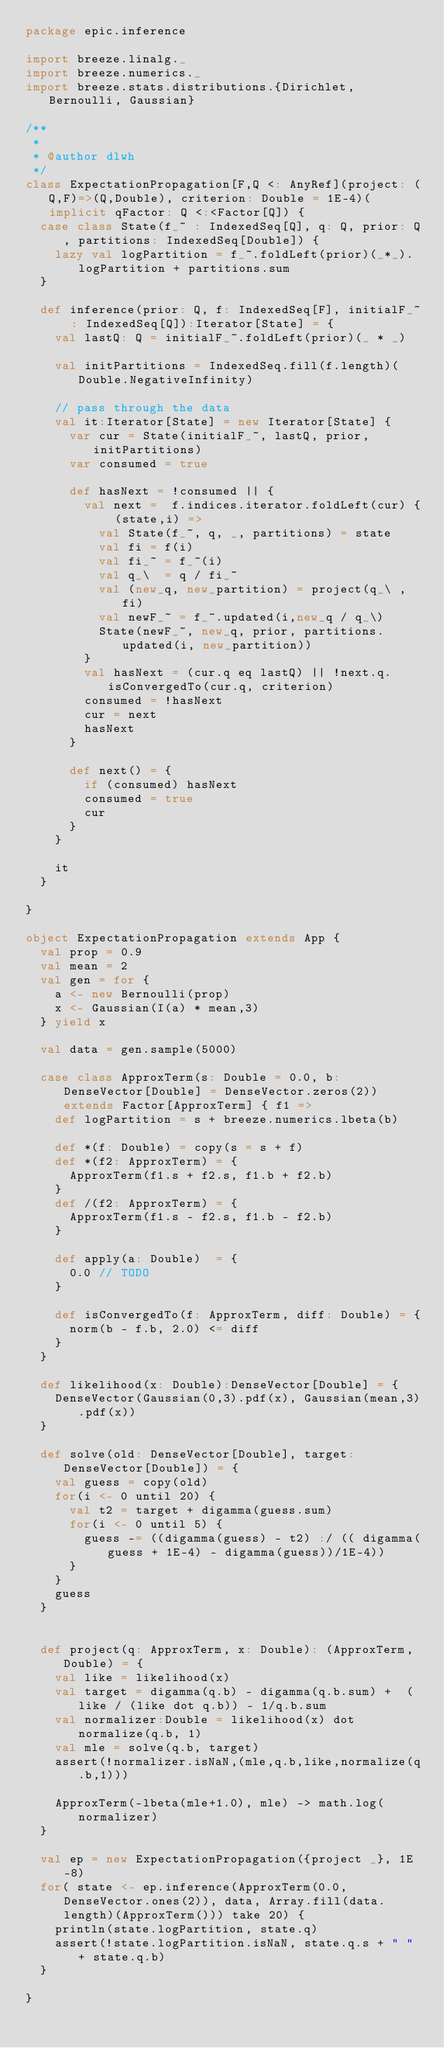<code> <loc_0><loc_0><loc_500><loc_500><_Scala_>package epic.inference

import breeze.linalg._
import breeze.numerics._
import breeze.stats.distributions.{Dirichlet, Bernoulli, Gaussian}

/**
 *
 * @author dlwh
 */
class ExpectationPropagation[F,Q <: AnyRef](project: (Q,F)=>(Q,Double), criterion: Double = 1E-4)(implicit qFactor: Q <:<Factor[Q]) {
  case class State(f_~ : IndexedSeq[Q], q: Q, prior: Q, partitions: IndexedSeq[Double]) {
    lazy val logPartition = f_~.foldLeft(prior)(_*_).logPartition + partitions.sum
  }

  def inference(prior: Q, f: IndexedSeq[F], initialF_~ : IndexedSeq[Q]):Iterator[State] = {
    val lastQ: Q = initialF_~.foldLeft(prior)(_ * _)

    val initPartitions = IndexedSeq.fill(f.length)(Double.NegativeInfinity)

    // pass through the data
    val it:Iterator[State] = new Iterator[State] {
      var cur = State(initialF_~, lastQ, prior, initPartitions)
      var consumed = true

      def hasNext = !consumed || {
        val next =  f.indices.iterator.foldLeft(cur) { (state,i) =>
          val State(f_~, q, _, partitions) = state
          val fi = f(i)
          val fi_~ = f_~(i)
          val q_\  = q / fi_~
          val (new_q, new_partition) = project(q_\ , fi)
          val newF_~ = f_~.updated(i,new_q / q_\)
          State(newF_~, new_q, prior, partitions.updated(i, new_partition))
        }
        val hasNext = (cur.q eq lastQ) || !next.q.isConvergedTo(cur.q, criterion)
        consumed = !hasNext
        cur = next
        hasNext
      }

      def next() = {
        if (consumed) hasNext
        consumed = true
        cur
      }
    }

    it
  }

}

object ExpectationPropagation extends App {
  val prop = 0.9
  val mean = 2
  val gen = for {
    a <- new Bernoulli(prop)
    x <- Gaussian(I(a) * mean,3)
  } yield x

  val data = gen.sample(5000)

  case class ApproxTerm(s: Double = 0.0, b: DenseVector[Double] = DenseVector.zeros(2)) extends Factor[ApproxTerm] { f1 =>
    def logPartition = s + breeze.numerics.lbeta(b)

    def *(f: Double) = copy(s = s + f)
    def *(f2: ApproxTerm) = {
      ApproxTerm(f1.s + f2.s, f1.b + f2.b)
    }
    def /(f2: ApproxTerm) = {
      ApproxTerm(f1.s - f2.s, f1.b - f2.b)
    }

    def apply(a: Double)  = {
      0.0 // TODO
    }

    def isConvergedTo(f: ApproxTerm, diff: Double) = {
      norm(b - f.b, 2.0) <= diff
    }
  }

  def likelihood(x: Double):DenseVector[Double] = {
    DenseVector(Gaussian(0,3).pdf(x), Gaussian(mean,3).pdf(x))
  }

  def solve(old: DenseVector[Double], target: DenseVector[Double]) = {
    val guess = copy(old)
    for(i <- 0 until 20) {
      val t2 = target + digamma(guess.sum)
      for(i <- 0 until 5) {
        guess -= ((digamma(guess) - t2) :/ (( digamma(guess + 1E-4) - digamma(guess))/1E-4))
      }
    }
    guess
  }


  def project(q: ApproxTerm, x: Double): (ApproxTerm, Double) = {
    val like = likelihood(x)
    val target = digamma(q.b) - digamma(q.b.sum) +  (like / (like dot q.b)) - 1/q.b.sum
    val normalizer:Double = likelihood(x) dot normalize(q.b, 1)
    val mle = solve(q.b, target)
    assert(!normalizer.isNaN,(mle,q.b,like,normalize(q.b,1)))

    ApproxTerm(-lbeta(mle+1.0), mle) -> math.log(normalizer)
  }

  val ep = new ExpectationPropagation({project _}, 1E-8)
  for( state <- ep.inference(ApproxTerm(0.0,DenseVector.ones(2)), data, Array.fill(data.length)(ApproxTerm())) take 20) {
    println(state.logPartition, state.q)
    assert(!state.logPartition.isNaN, state.q.s + " " + state.q.b)
  }

}

</code> 